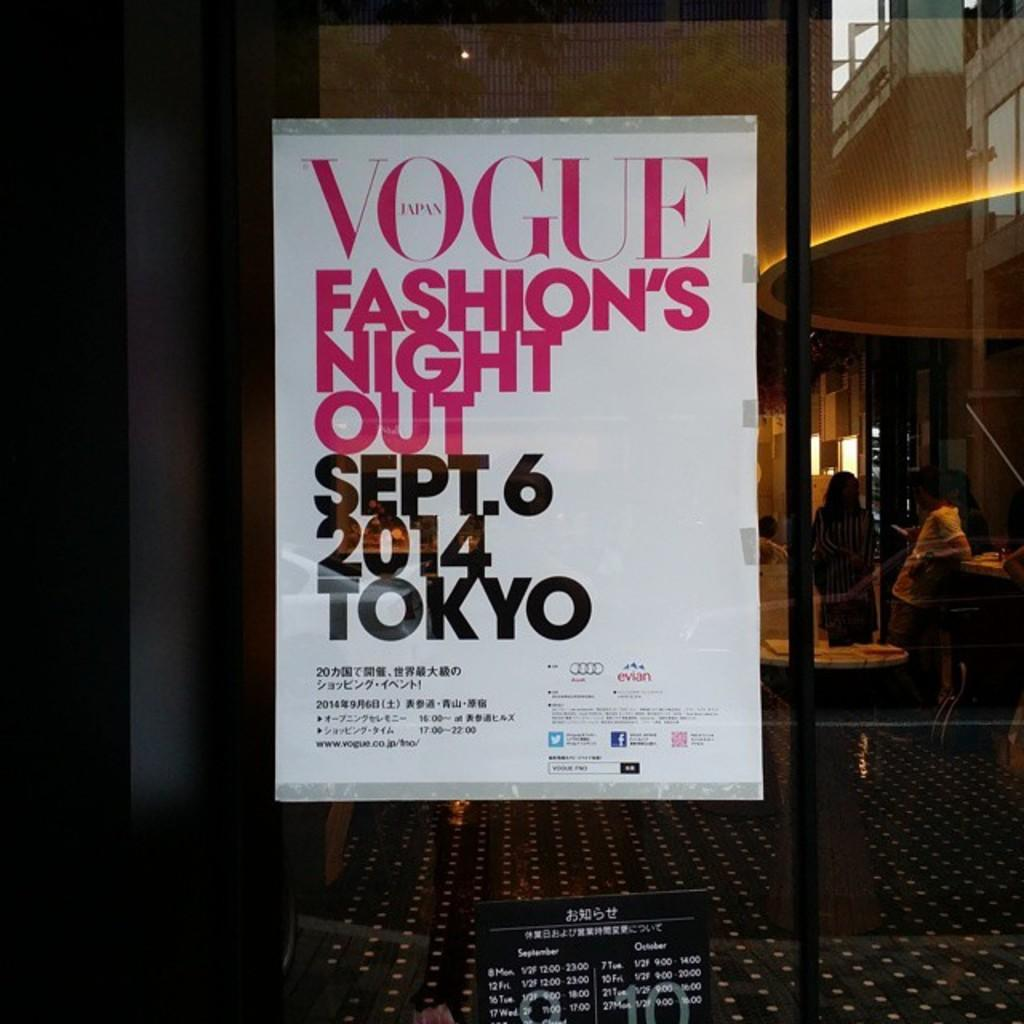<image>
Share a concise interpretation of the image provided. An ad is for Vogue Fashion's Night Out in Tokyo. 